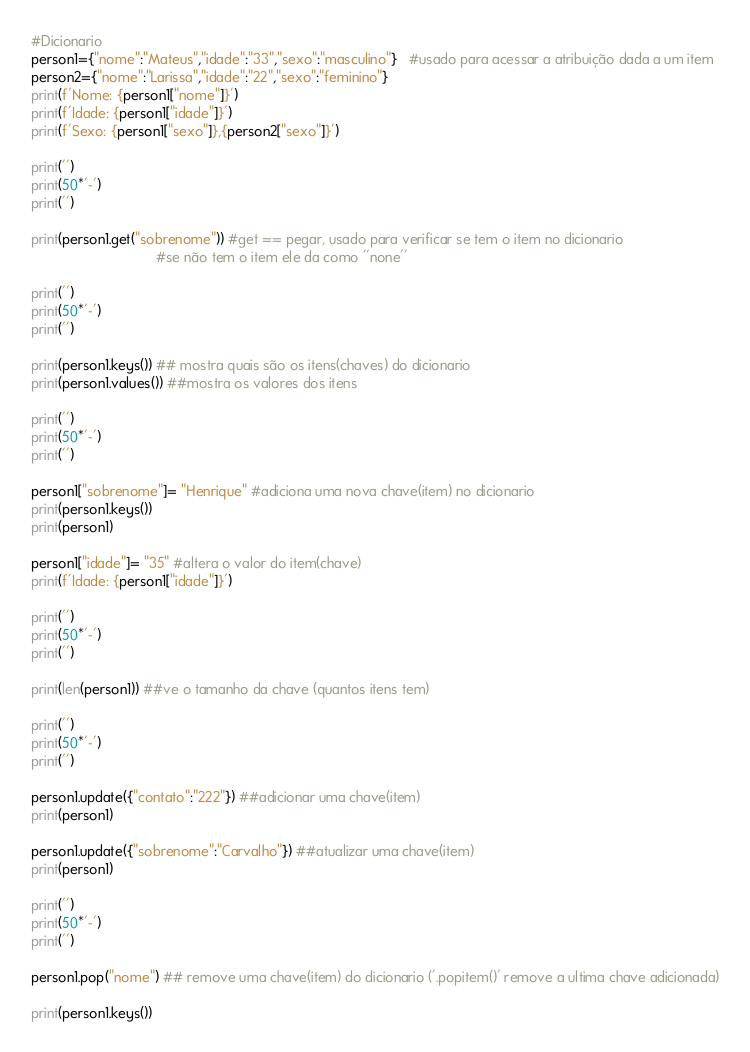Convert code to text. <code><loc_0><loc_0><loc_500><loc_500><_Python_>#Dicionario
person1={"nome":"Mateus","idade":"33","sexo":"masculino"}   #usado para acessar a atribuição dada a um item
person2={"nome":"Larissa","idade":"22","sexo":"feminino"}
print(f'Nome: {person1["nome"]}')
print(f'Idade: {person1["idade"]}')
print(f'Sexo: {person1["sexo"]},{person2["sexo"]}')

print('')
print(50*'-')
print('')

print(person1.get("sobrenome")) #get == pegar, usado para verificar se tem o item no dicionario 
                                #se não tem o item ele da como ''none''

print('')
print(50*'-')
print('')

print(person1.keys()) ## mostra quais são os itens(chaves) do dicionario
print(person1.values()) ##mostra os valores dos itens

print('')
print(50*'-')
print('')

person1["sobrenome"]= "Henrique" #adiciona uma nova chave(item) no dicionario
print(person1.keys())
print(person1)

person1["idade"]= "35" #altera o valor do item(chave)
print(f'Idade: {person1["idade"]}')

print('')
print(50*'-')
print('')

print(len(person1)) ##ve o tamanho da chave (quantos itens tem)

print('')
print(50*'-')
print('')

person1.update({"contato":"222"}) ##adicionar uma chave(item)
print(person1)

person1.update({"sobrenome":"Carvalho"}) ##atualizar uma chave(item)
print(person1)

print('')
print(50*'-')
print('')

person1.pop("nome") ## remove uma chave(item) do dicionario ('.popitem()' remove a ultima chave adicionada)

print(person1.keys())</code> 